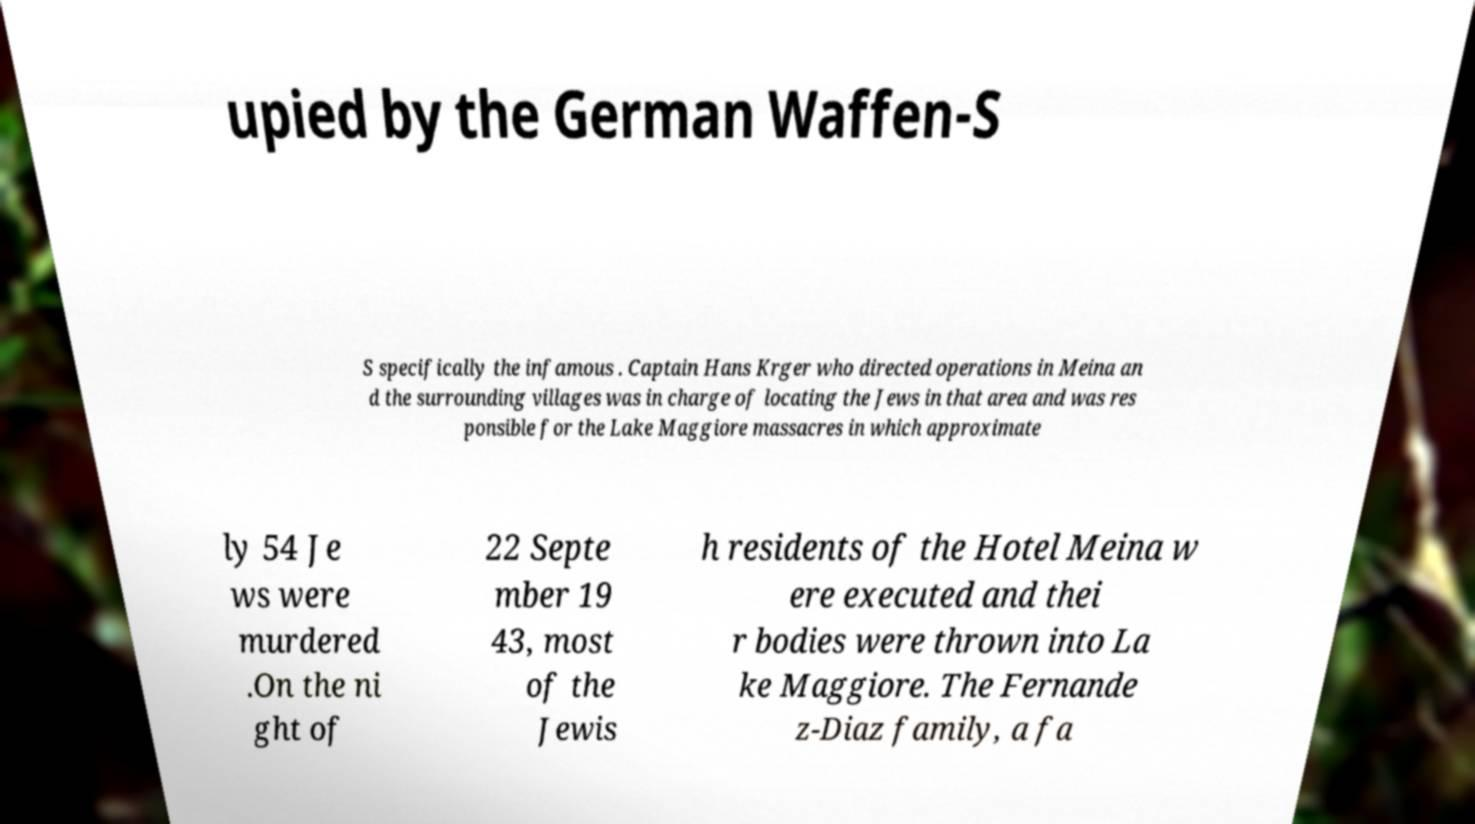What messages or text are displayed in this image? I need them in a readable, typed format. upied by the German Waffen-S S specifically the infamous . Captain Hans Krger who directed operations in Meina an d the surrounding villages was in charge of locating the Jews in that area and was res ponsible for the Lake Maggiore massacres in which approximate ly 54 Je ws were murdered .On the ni ght of 22 Septe mber 19 43, most of the Jewis h residents of the Hotel Meina w ere executed and thei r bodies were thrown into La ke Maggiore. The Fernande z-Diaz family, a fa 